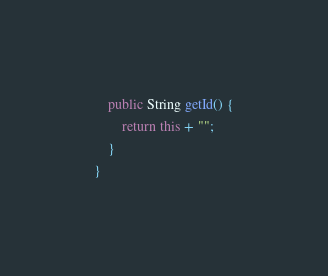<code> <loc_0><loc_0><loc_500><loc_500><_Java_>
    public String getId() {
        return this + "";
    }
}
</code> 